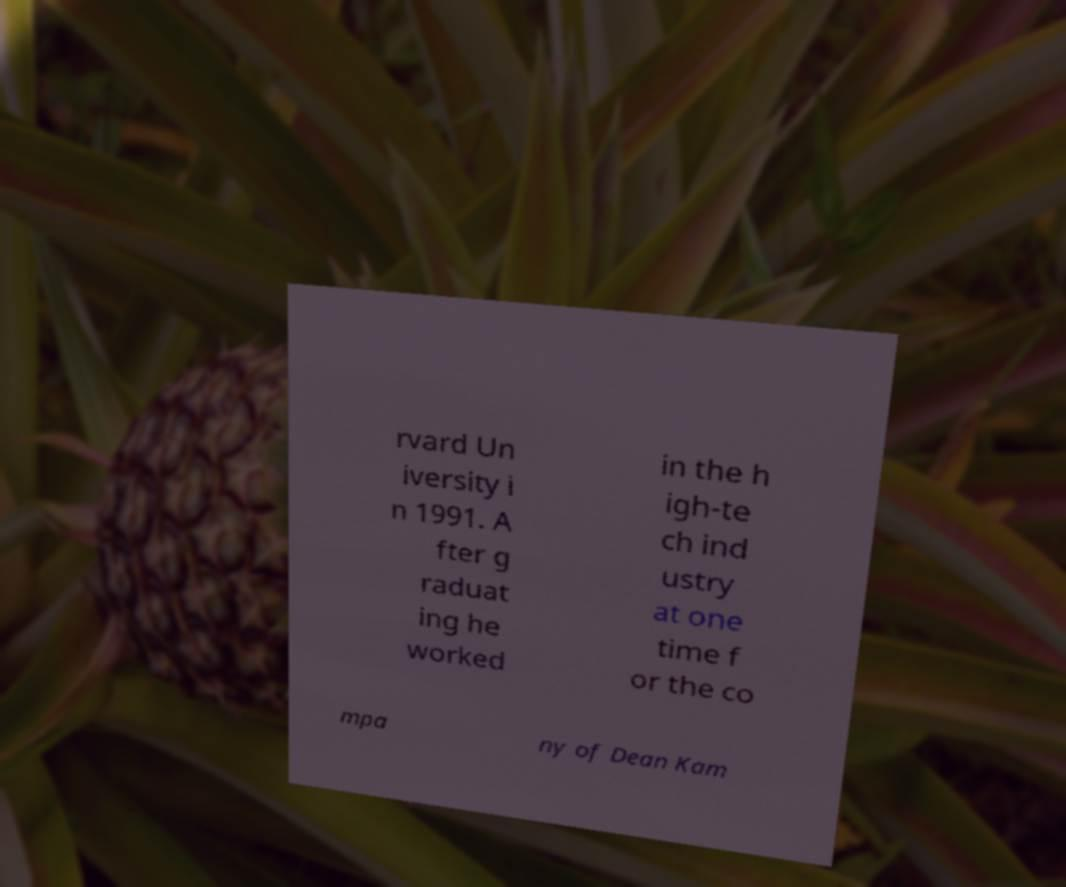Please read and relay the text visible in this image. What does it say? rvard Un iversity i n 1991. A fter g raduat ing he worked in the h igh-te ch ind ustry at one time f or the co mpa ny of Dean Kam 